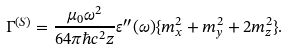Convert formula to latex. <formula><loc_0><loc_0><loc_500><loc_500>\Gamma ^ { ( S ) } = \frac { \mu _ { 0 } \omega ^ { 2 } } { 6 4 \pi \hbar { c } ^ { 2 } z } \varepsilon ^ { \prime \prime } ( \omega ) \{ m _ { x } ^ { 2 } + m _ { y } ^ { 2 } + 2 m _ { z } ^ { 2 } \} .</formula> 